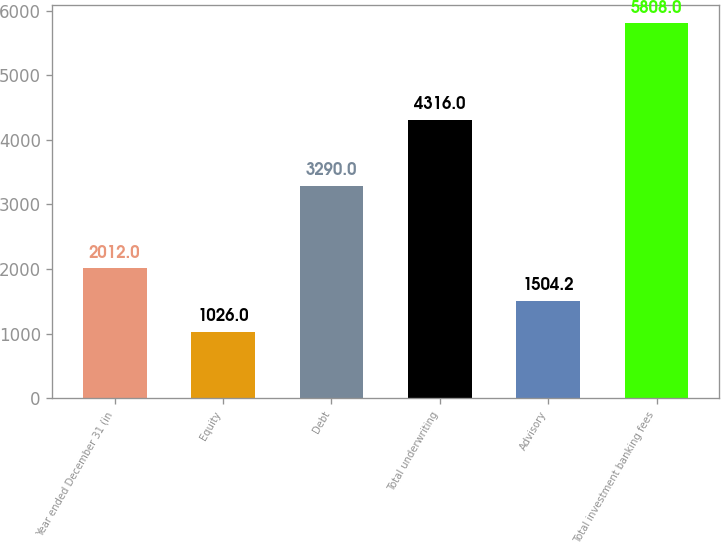Convert chart to OTSL. <chart><loc_0><loc_0><loc_500><loc_500><bar_chart><fcel>Year ended December 31 (in<fcel>Equity<fcel>Debt<fcel>Total underwriting<fcel>Advisory<fcel>Total investment banking fees<nl><fcel>2012<fcel>1026<fcel>3290<fcel>4316<fcel>1504.2<fcel>5808<nl></chart> 